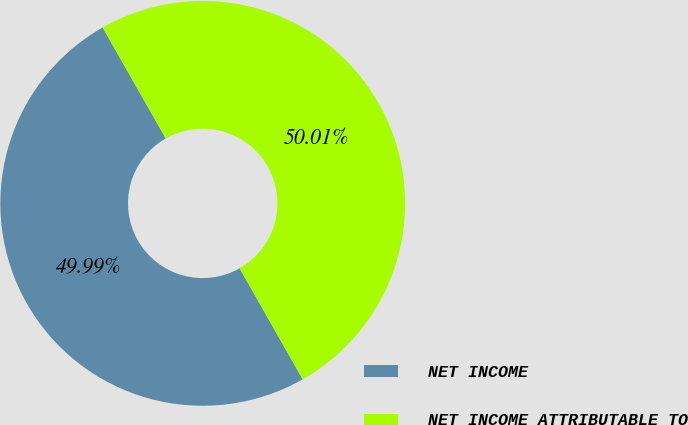Convert chart. <chart><loc_0><loc_0><loc_500><loc_500><pie_chart><fcel>NET INCOME<fcel>NET INCOME ATTRIBUTABLE TO<nl><fcel>49.99%<fcel>50.01%<nl></chart> 